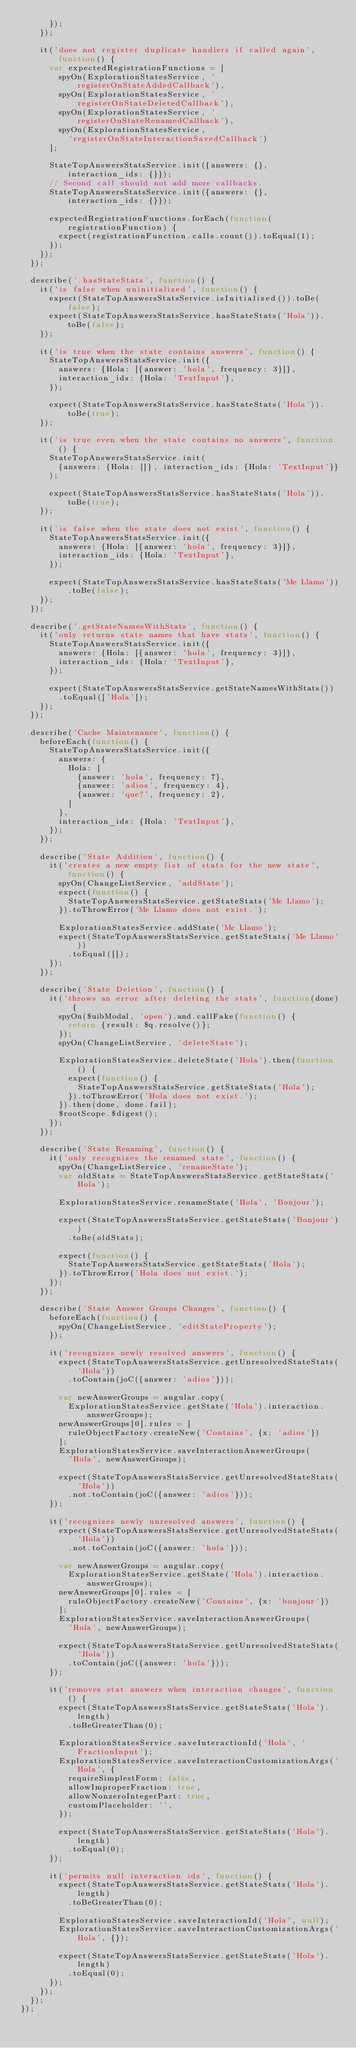Convert code to text. <code><loc_0><loc_0><loc_500><loc_500><_TypeScript_>      });
    });

    it('does not register duplicate handlers if called again', function() {
      var expectedRegistrationFunctions = [
        spyOn(ExplorationStatesService, 'registerOnStateAddedCallback'),
        spyOn(ExplorationStatesService, 'registerOnStateDeletedCallback'),
        spyOn(ExplorationStatesService, 'registerOnStateRenamedCallback'),
        spyOn(ExplorationStatesService,
          'registerOnStateInteractionSavedCallback')
      ];

      StateTopAnswersStatsService.init({answers: {}, interaction_ids: {}});
      // Second call should not add more callbacks.
      StateTopAnswersStatsService.init({answers: {}, interaction_ids: {}});

      expectedRegistrationFunctions.forEach(function(registrationFunction) {
        expect(registrationFunction.calls.count()).toEqual(1);
      });
    });
  });

  describe('.hasStateStats', function() {
    it('is false when uninitialized', function() {
      expect(StateTopAnswersStatsService.isInitialized()).toBe(false);
      expect(StateTopAnswersStatsService.hasStateStats('Hola')).toBe(false);
    });

    it('is true when the state contains answers', function() {
      StateTopAnswersStatsService.init({
        answers: {Hola: [{answer: 'hola', frequency: 3}]},
        interaction_ids: {Hola: 'TextInput'},
      });

      expect(StateTopAnswersStatsService.hasStateStats('Hola')).toBe(true);
    });

    it('is true even when the state contains no answers', function() {
      StateTopAnswersStatsService.init(
        {answers: {Hola: []}, interaction_ids: {Hola: 'TextInput'}}
      );

      expect(StateTopAnswersStatsService.hasStateStats('Hola')).toBe(true);
    });

    it('is false when the state does not exist', function() {
      StateTopAnswersStatsService.init({
        answers: {Hola: [{answer: 'hola', frequency: 3}]},
        interaction_ids: {Hola: 'TextInput'},
      });

      expect(StateTopAnswersStatsService.hasStateStats('Me Llamo')).toBe(false);
    });
  });

  describe('.getStateNamesWithStats', function() {
    it('only returns state names that have stats', function() {
      StateTopAnswersStatsService.init({
        answers: {Hola: [{answer: 'hola', frequency: 3}]},
        interaction_ids: {Hola: 'TextInput'},
      });

      expect(StateTopAnswersStatsService.getStateNamesWithStats())
        .toEqual(['Hola']);
    });
  });

  describe('Cache Maintenance', function() {
    beforeEach(function() {
      StateTopAnswersStatsService.init({
        answers: {
          Hola: [
            {answer: 'hola', frequency: 7},
            {answer: 'adios', frequency: 4},
            {answer: 'que?', frequency: 2},
          ]
        },
        interaction_ids: {Hola: 'TextInput'},
      });
    });

    describe('State Addition', function() {
      it('creates a new empty list of stats for the new state', function() {
        spyOn(ChangeListService, 'addState');
        expect(function() {
          StateTopAnswersStatsService.getStateStats('Me Llamo');
        }).toThrowError('Me Llamo does not exist.');

        ExplorationStatesService.addState('Me Llamo');
        expect(StateTopAnswersStatsService.getStateStats('Me Llamo'))
          .toEqual([]);
      });
    });

    describe('State Deletion', function() {
      it('throws an error after deleting the stats', function(done) {
        spyOn($uibModal, 'open').and.callFake(function() {
          return {result: $q.resolve()};
        });
        spyOn(ChangeListService, 'deleteState');

        ExplorationStatesService.deleteState('Hola').then(function() {
          expect(function() {
            StateTopAnswersStatsService.getStateStats('Hola');
          }).toThrowError('Hola does not exist.');
        }).then(done, done.fail);
        $rootScope.$digest();
      });
    });

    describe('State Renaming', function() {
      it('only recognizes the renamed state', function() {
        spyOn(ChangeListService, 'renameState');
        var oldStats = StateTopAnswersStatsService.getStateStats('Hola');

        ExplorationStatesService.renameState('Hola', 'Bonjour');

        expect(StateTopAnswersStatsService.getStateStats('Bonjour'))
          .toBe(oldStats);

        expect(function() {
          StateTopAnswersStatsService.getStateStats('Hola');
        }).toThrowError('Hola does not exist.');
      });
    });

    describe('State Answer Groups Changes', function() {
      beforeEach(function() {
        spyOn(ChangeListService, 'editStateProperty');
      });

      it('recognizes newly resolved answers', function() {
        expect(StateTopAnswersStatsService.getUnresolvedStateStats('Hola'))
          .toContain(joC({answer: 'adios'}));

        var newAnswerGroups = angular.copy(
          ExplorationStatesService.getState('Hola').interaction.answerGroups);
        newAnswerGroups[0].rules = [
          ruleObjectFactory.createNew('Contains', {x: 'adios'})
        ];
        ExplorationStatesService.saveInteractionAnswerGroups(
          'Hola', newAnswerGroups);

        expect(StateTopAnswersStatsService.getUnresolvedStateStats('Hola'))
          .not.toContain(joC({answer: 'adios'}));
      });

      it('recognizes newly unresolved answers', function() {
        expect(StateTopAnswersStatsService.getUnresolvedStateStats('Hola'))
          .not.toContain(joC({answer: 'hola'}));

        var newAnswerGroups = angular.copy(
          ExplorationStatesService.getState('Hola').interaction.answerGroups);
        newAnswerGroups[0].rules = [
          ruleObjectFactory.createNew('Contains', {x: 'bonjour'})
        ];
        ExplorationStatesService.saveInteractionAnswerGroups(
          'Hola', newAnswerGroups);

        expect(StateTopAnswersStatsService.getUnresolvedStateStats('Hola'))
          .toContain(joC({answer: 'hola'}));
      });

      it('removes stat answers when interaction changes', function() {
        expect(StateTopAnswersStatsService.getStateStats('Hola').length)
          .toBeGreaterThan(0);

        ExplorationStatesService.saveInteractionId('Hola', 'FractionInput');
        ExplorationStatesService.saveInteractionCustomizationArgs('Hola', {
          requireSimplestForm: false,
          allowImproperFraction: true,
          allowNonzeroIntegerPart: true,
          customPlaceholder: '',
        });

        expect(StateTopAnswersStatsService.getStateStats('Hola').length)
          .toEqual(0);
      });

      it('permits null interaction ids', function() {
        expect(StateTopAnswersStatsService.getStateStats('Hola').length)
          .toBeGreaterThan(0);

        ExplorationStatesService.saveInteractionId('Hola', null);
        ExplorationStatesService.saveInteractionCustomizationArgs('Hola', {});

        expect(StateTopAnswersStatsService.getStateStats('Hola').length)
          .toEqual(0);
      });
    });
  });
});
</code> 